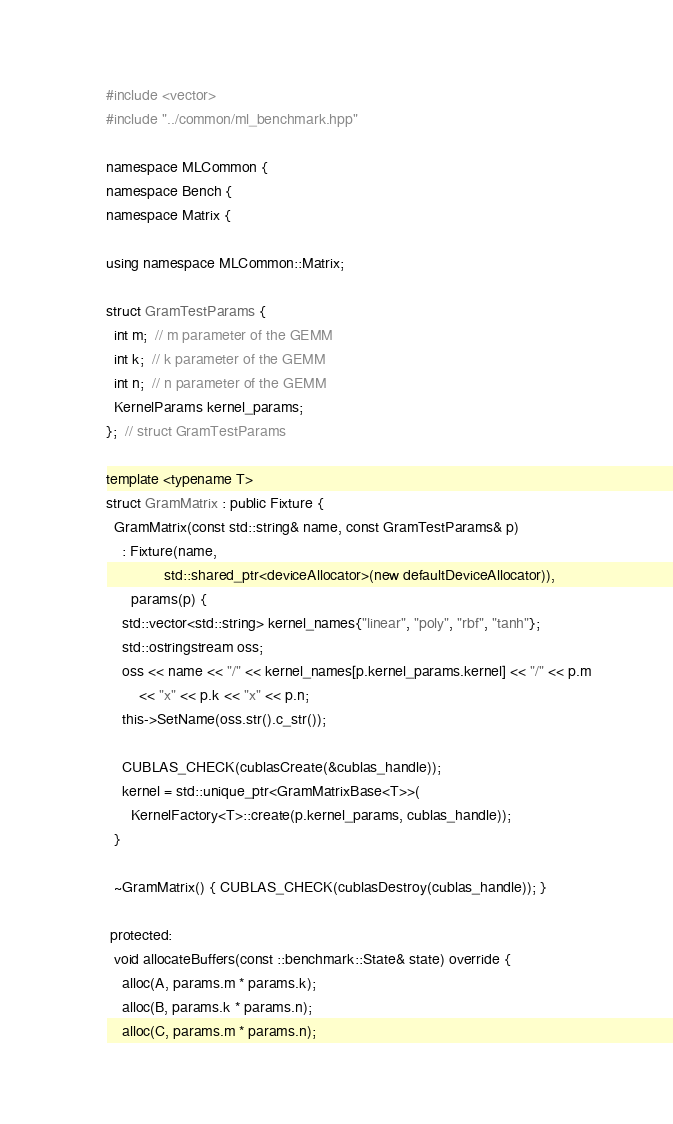Convert code to text. <code><loc_0><loc_0><loc_500><loc_500><_Cuda_>#include <vector>
#include "../common/ml_benchmark.hpp"

namespace MLCommon {
namespace Bench {
namespace Matrix {

using namespace MLCommon::Matrix;

struct GramTestParams {
  int m;  // m parameter of the GEMM
  int k;  // k parameter of the GEMM
  int n;  // n parameter of the GEMM
  KernelParams kernel_params;
};  // struct GramTestParams

template <typename T>
struct GramMatrix : public Fixture {
  GramMatrix(const std::string& name, const GramTestParams& p)
    : Fixture(name,
              std::shared_ptr<deviceAllocator>(new defaultDeviceAllocator)),
      params(p) {
    std::vector<std::string> kernel_names{"linear", "poly", "rbf", "tanh"};
    std::ostringstream oss;
    oss << name << "/" << kernel_names[p.kernel_params.kernel] << "/" << p.m
        << "x" << p.k << "x" << p.n;
    this->SetName(oss.str().c_str());

    CUBLAS_CHECK(cublasCreate(&cublas_handle));
    kernel = std::unique_ptr<GramMatrixBase<T>>(
      KernelFactory<T>::create(p.kernel_params, cublas_handle));
  }

  ~GramMatrix() { CUBLAS_CHECK(cublasDestroy(cublas_handle)); }

 protected:
  void allocateBuffers(const ::benchmark::State& state) override {
    alloc(A, params.m * params.k);
    alloc(B, params.k * params.n);
    alloc(C, params.m * params.n);</code> 